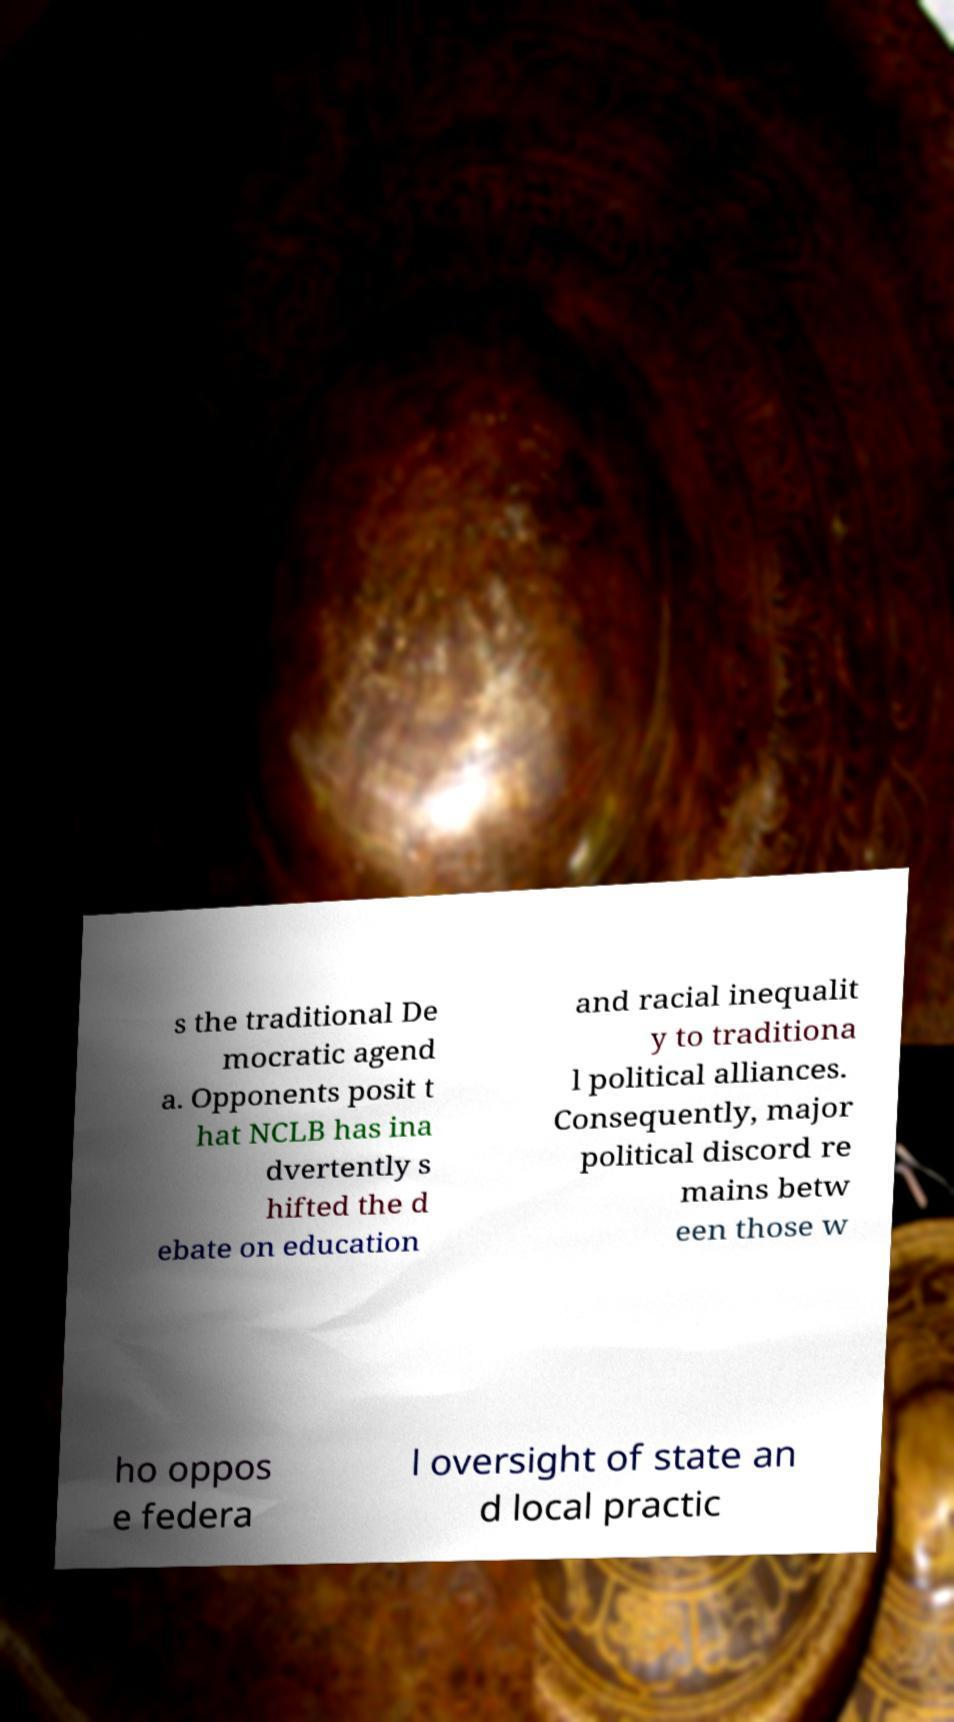What messages or text are displayed in this image? I need them in a readable, typed format. s the traditional De mocratic agend a. Opponents posit t hat NCLB has ina dvertently s hifted the d ebate on education and racial inequalit y to traditiona l political alliances. Consequently, major political discord re mains betw een those w ho oppos e federa l oversight of state an d local practic 